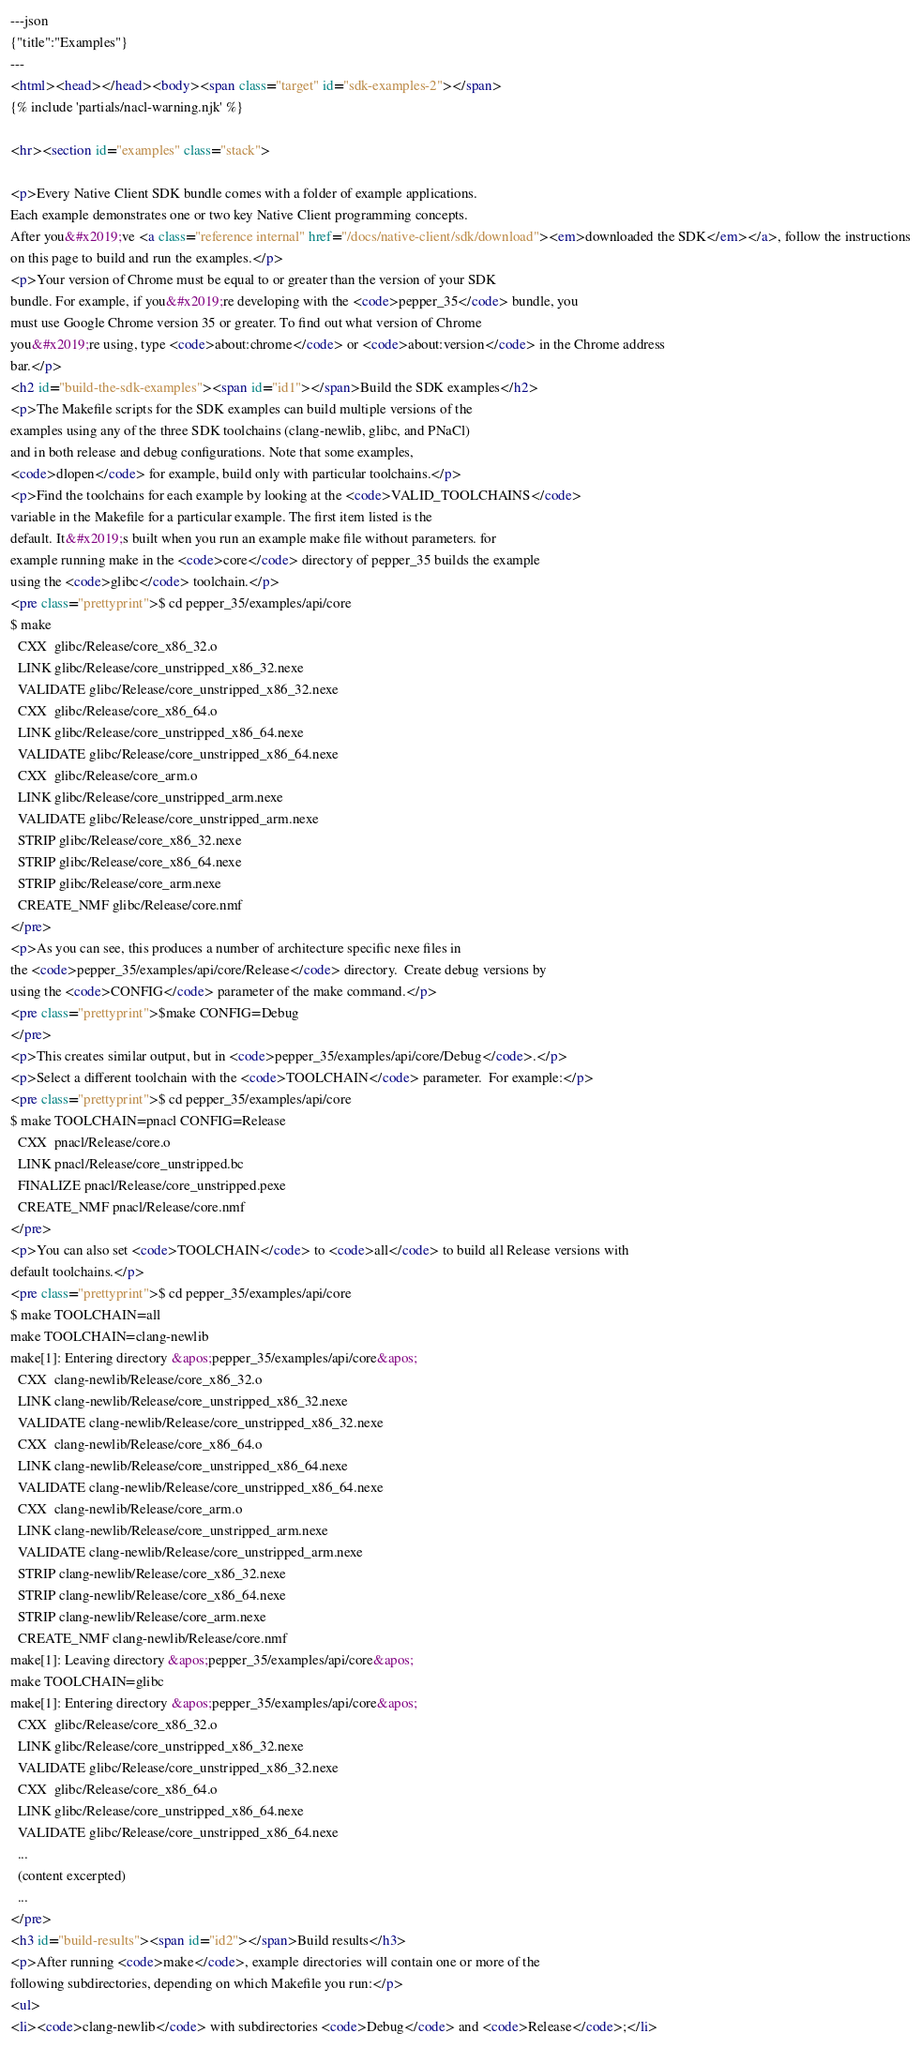Convert code to text. <code><loc_0><loc_0><loc_500><loc_500><_HTML_>---json
{"title":"Examples"}
---
<html><head></head><body><span class="target" id="sdk-examples-2"></span>
{% include 'partials/nacl-warning.njk' %}

<hr><section id="examples" class="stack">

<p>Every Native Client SDK bundle comes with a folder of example applications.
Each example demonstrates one or two key Native Client programming concepts.
After you&#x2019;ve <a class="reference internal" href="/docs/native-client/sdk/download"><em>downloaded the SDK</em></a>, follow the instructions
on this page to build and run the examples.</p>
<p>Your version of Chrome must be equal to or greater than the version of your SDK
bundle. For example, if you&#x2019;re developing with the <code>pepper_35</code> bundle, you
must use Google Chrome version 35 or greater. To find out what version of Chrome
you&#x2019;re using, type <code>about:chrome</code> or <code>about:version</code> in the Chrome address
bar.</p>
<h2 id="build-the-sdk-examples"><span id="id1"></span>Build the SDK examples</h2>
<p>The Makefile scripts for the SDK examples can build multiple versions of the
examples using any of the three SDK toolchains (clang-newlib, glibc, and PNaCl)
and in both release and debug configurations. Note that some examples,
<code>dlopen</code> for example, build only with particular toolchains.</p>
<p>Find the toolchains for each example by looking at the <code>VALID_TOOLCHAINS</code>
variable in the Makefile for a particular example. The first item listed is the
default. It&#x2019;s built when you run an example make file without parameters. for
example running make in the <code>core</code> directory of pepper_35 builds the example
using the <code>glibc</code> toolchain.</p>
<pre class="prettyprint">$ cd pepper_35/examples/api/core
$ make
  CXX  glibc/Release/core_x86_32.o
  LINK glibc/Release/core_unstripped_x86_32.nexe
  VALIDATE glibc/Release/core_unstripped_x86_32.nexe
  CXX  glibc/Release/core_x86_64.o
  LINK glibc/Release/core_unstripped_x86_64.nexe
  VALIDATE glibc/Release/core_unstripped_x86_64.nexe
  CXX  glibc/Release/core_arm.o
  LINK glibc/Release/core_unstripped_arm.nexe
  VALIDATE glibc/Release/core_unstripped_arm.nexe
  STRIP glibc/Release/core_x86_32.nexe
  STRIP glibc/Release/core_x86_64.nexe
  STRIP glibc/Release/core_arm.nexe
  CREATE_NMF glibc/Release/core.nmf
</pre>
<p>As you can see, this produces a number of architecture specific nexe files in
the <code>pepper_35/examples/api/core/Release</code> directory.  Create debug versions by
using the <code>CONFIG</code> parameter of the make command.</p>
<pre class="prettyprint">$make CONFIG=Debug
</pre>
<p>This creates similar output, but in <code>pepper_35/examples/api/core/Debug</code>.</p>
<p>Select a different toolchain with the <code>TOOLCHAIN</code> parameter.  For example:</p>
<pre class="prettyprint">$ cd pepper_35/examples/api/core
$ make TOOLCHAIN=pnacl CONFIG=Release
  CXX  pnacl/Release/core.o
  LINK pnacl/Release/core_unstripped.bc
  FINALIZE pnacl/Release/core_unstripped.pexe
  CREATE_NMF pnacl/Release/core.nmf
</pre>
<p>You can also set <code>TOOLCHAIN</code> to <code>all</code> to build all Release versions with
default toolchains.</p>
<pre class="prettyprint">$ cd pepper_35/examples/api/core
$ make TOOLCHAIN=all
make TOOLCHAIN=clang-newlib
make[1]: Entering directory &apos;pepper_35/examples/api/core&apos;
  CXX  clang-newlib/Release/core_x86_32.o
  LINK clang-newlib/Release/core_unstripped_x86_32.nexe
  VALIDATE clang-newlib/Release/core_unstripped_x86_32.nexe
  CXX  clang-newlib/Release/core_x86_64.o
  LINK clang-newlib/Release/core_unstripped_x86_64.nexe
  VALIDATE clang-newlib/Release/core_unstripped_x86_64.nexe
  CXX  clang-newlib/Release/core_arm.o
  LINK clang-newlib/Release/core_unstripped_arm.nexe
  VALIDATE clang-newlib/Release/core_unstripped_arm.nexe
  STRIP clang-newlib/Release/core_x86_32.nexe
  STRIP clang-newlib/Release/core_x86_64.nexe
  STRIP clang-newlib/Release/core_arm.nexe
  CREATE_NMF clang-newlib/Release/core.nmf
make[1]: Leaving directory &apos;pepper_35/examples/api/core&apos;
make TOOLCHAIN=glibc
make[1]: Entering directory &apos;pepper_35/examples/api/core&apos;
  CXX  glibc/Release/core_x86_32.o
  LINK glibc/Release/core_unstripped_x86_32.nexe
  VALIDATE glibc/Release/core_unstripped_x86_32.nexe
  CXX  glibc/Release/core_x86_64.o
  LINK glibc/Release/core_unstripped_x86_64.nexe
  VALIDATE glibc/Release/core_unstripped_x86_64.nexe
  ...
  (content excerpted)
  ...
</pre>
<h3 id="build-results"><span id="id2"></span>Build results</h3>
<p>After running <code>make</code>, example directories will contain one or more of the
following subdirectories, depending on which Makefile you run:</p>
<ul>
<li><code>clang-newlib</code> with subdirectories <code>Debug</code> and <code>Release</code>;</li></code> 